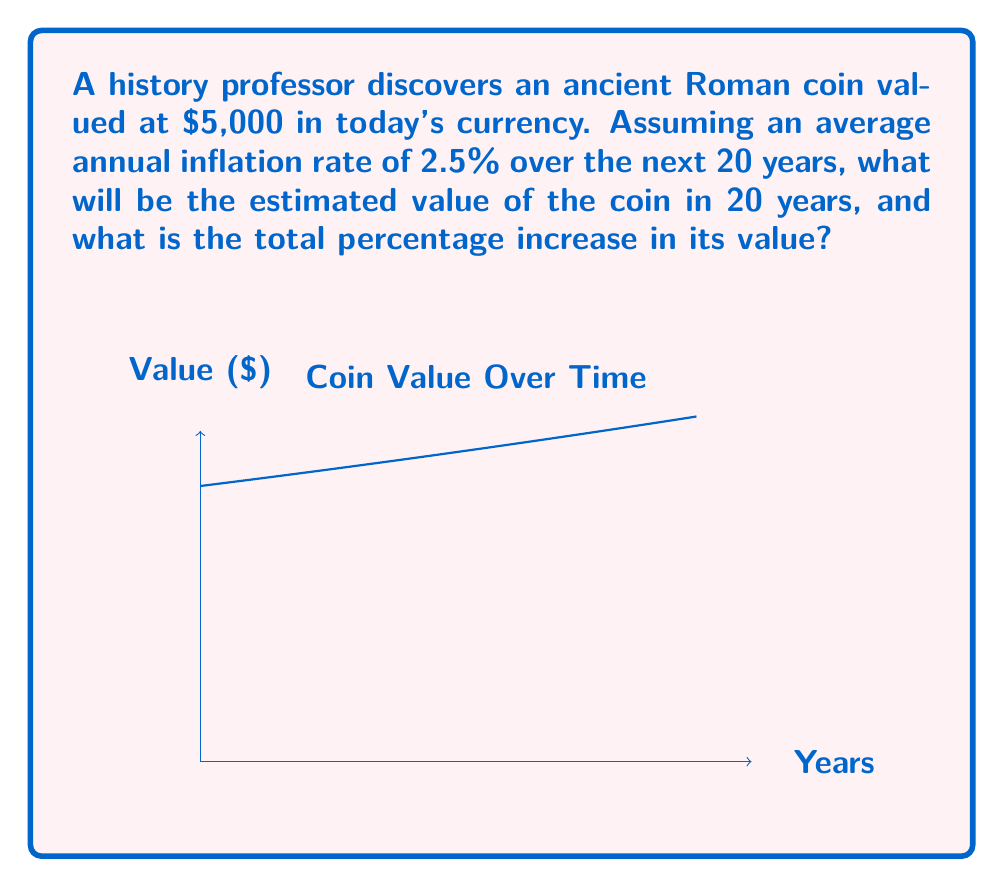Can you solve this math problem? To solve this problem, we'll use the compound interest formula, which is applicable to inflation calculations:

1) The formula for future value with continuous compounding is:
   $$FV = PV \cdot e^{rt}$$
   Where:
   FV = Future Value
   PV = Present Value
   e = Euler's number (approximately 2.71828)
   r = Annual inflation rate
   t = Time in years

2) Given:
   PV = $5,000
   r = 2.5% = 0.025
   t = 20 years

3) Plugging these values into the formula:
   $$FV = 5000 \cdot e^{0.025 \cdot 20}$$

4) Calculating:
   $$FV = 5000 \cdot e^{0.5} \approx 5000 \cdot 1.6487 \approx 8243.50$$

5) To calculate the percentage increase:
   Percentage increase = $\frac{FV - PV}{PV} \cdot 100\%$
   $$= \frac{8243.50 - 5000}{5000} \cdot 100\% \approx 64.87\%$$

Therefore, in 20 years, the coin will be valued at approximately $8,243.50, representing a 64.87% increase from its original value.
Answer: $8,243.50; 64.87% 